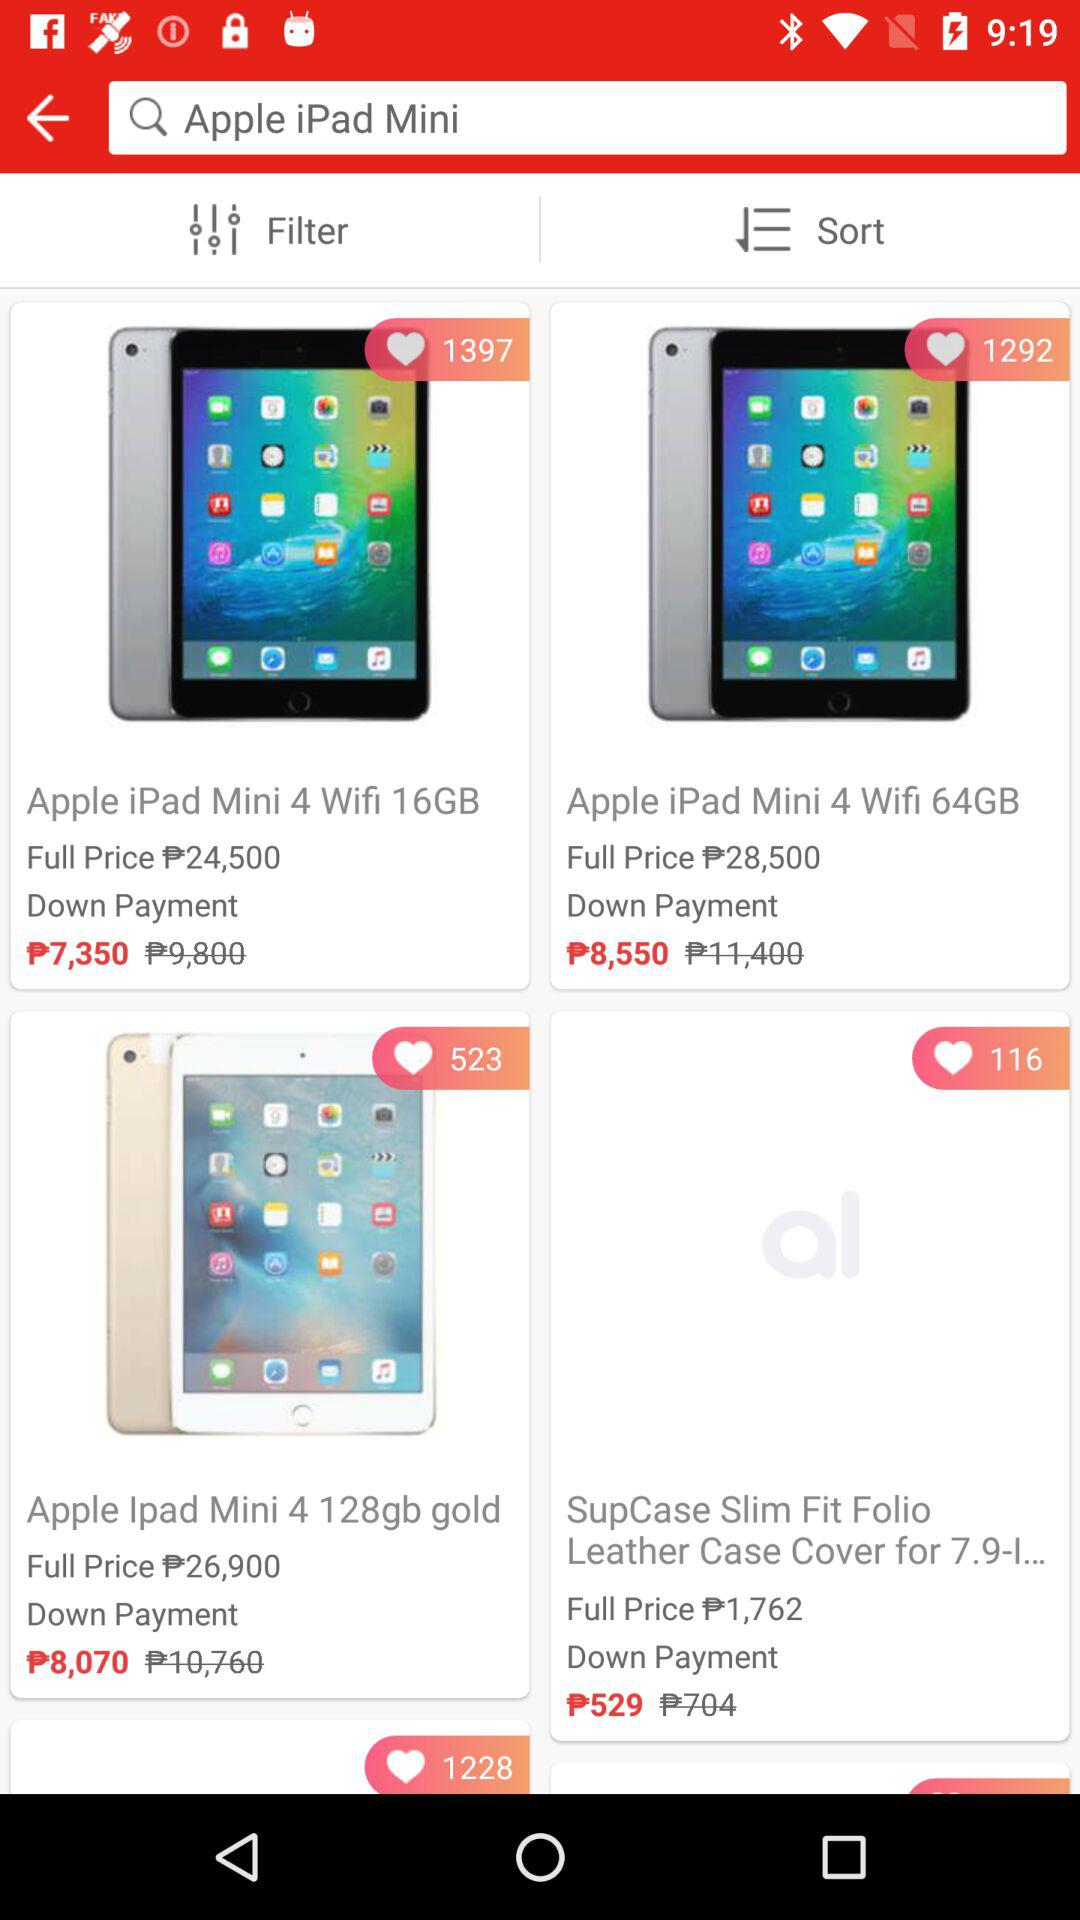What is the price of an "Apple iPad Mini 4 Wifi 64GB"? The price is ₱28,500. 